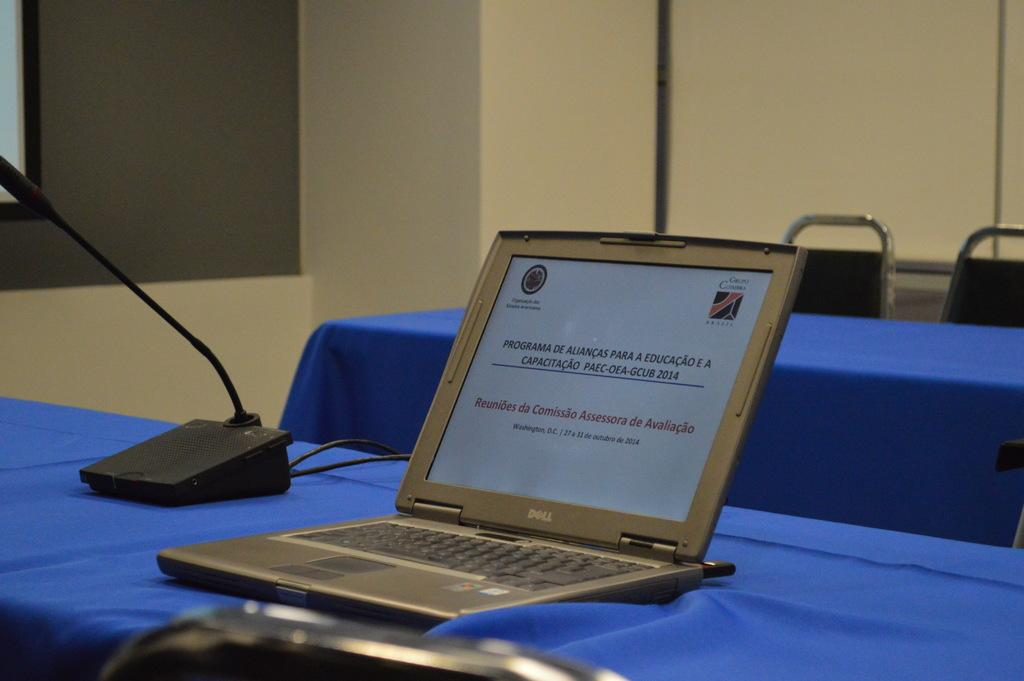<image>
Relay a brief, clear account of the picture shown. A Dell Laptop is displaying a slideshow in a conference room. 